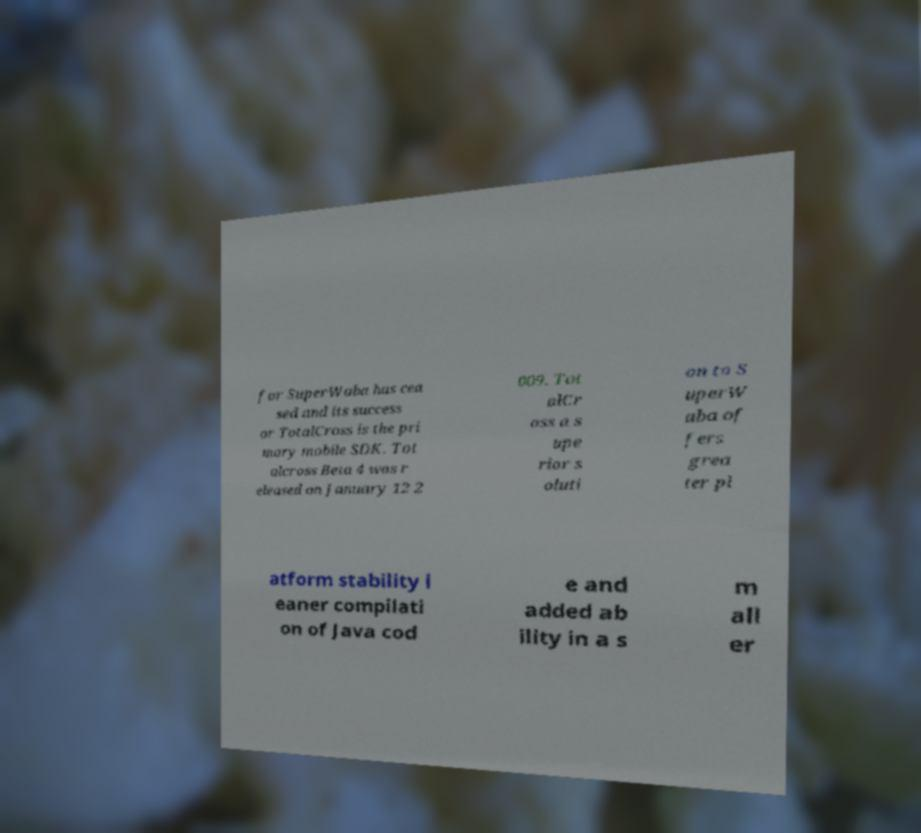I need the written content from this picture converted into text. Can you do that? for SuperWaba has cea sed and its success or TotalCross is the pri mary mobile SDK. Tot alcross Beta 4 was r eleased on January 12 2 009. Tot alCr oss a s upe rior s oluti on to S uperW aba of fers grea ter pl atform stability l eaner compilati on of Java cod e and added ab ility in a s m all er 